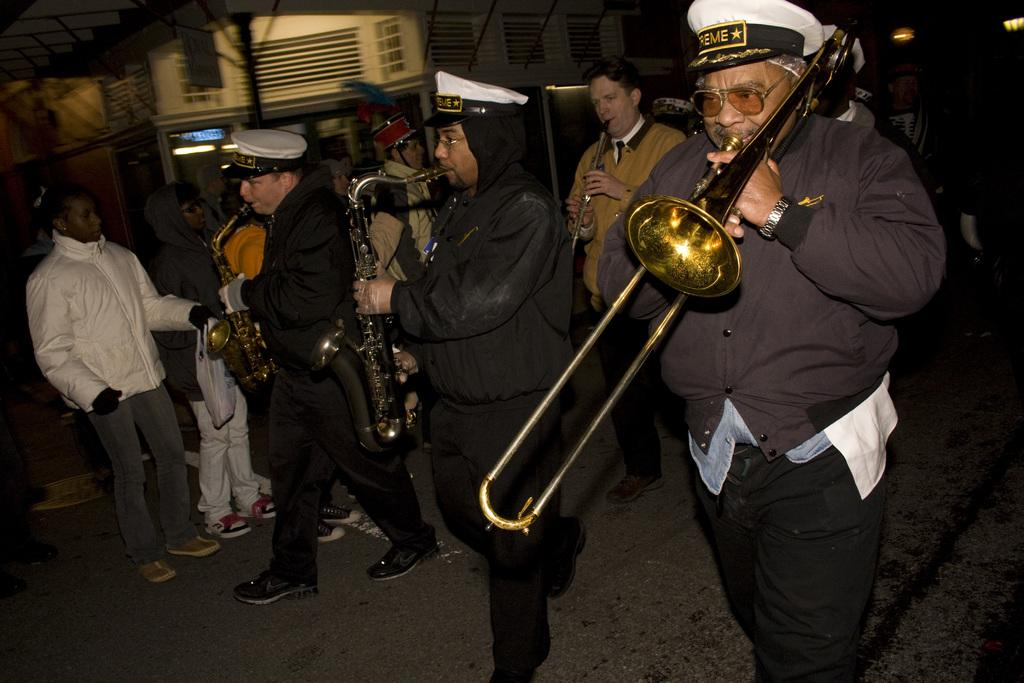What are the main subjects in the center of the image? There are persons playing musical instruments in the center of the image. What are the people on the left side of the image doing? There are persons standing on the left side of the image. What can be seen in the background of the image? There is a building and a pole in the background of the image. How does the clam express regret in the image? There is no clam present in the image, and therefore no such expression can be observed. 